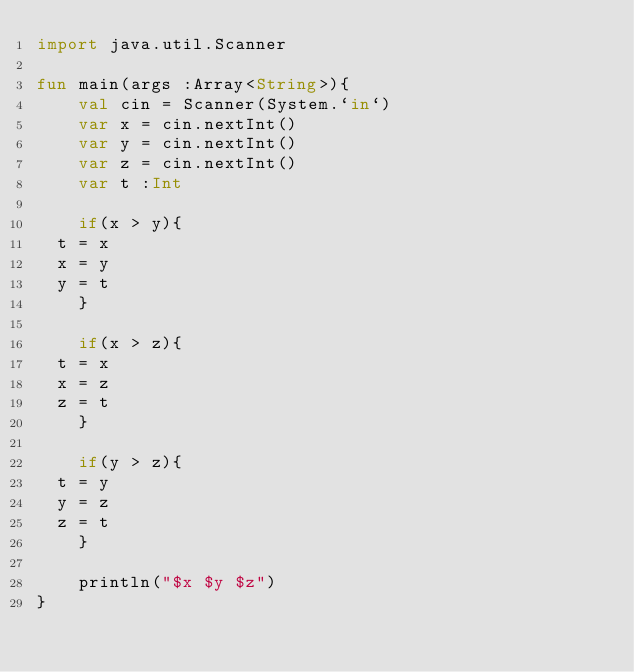Convert code to text. <code><loc_0><loc_0><loc_500><loc_500><_Kotlin_>import java.util.Scanner

fun main(args :Array<String>){
    val cin = Scanner(System.`in`)
    var x = cin.nextInt()
    var y = cin.nextInt()
    var z = cin.nextInt()
    var t :Int

    if(x > y){
	t = x
	x = y
	y = t
    }

    if(x > z){
	t = x
	x = z
	z = t
    }

    if(y > z){
	t = y
	y = z
	z = t
    }

    println("$x $y $z")
}

</code> 